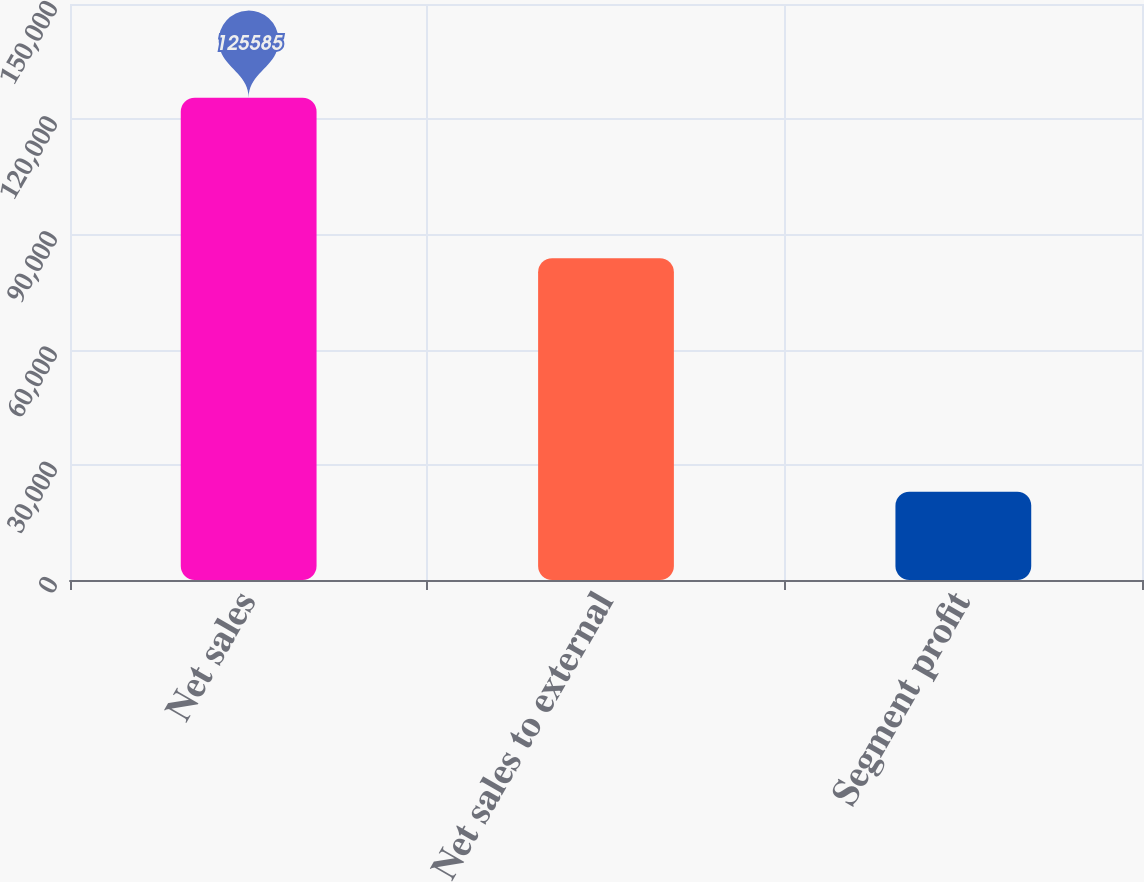<chart> <loc_0><loc_0><loc_500><loc_500><bar_chart><fcel>Net sales<fcel>Net sales to external<fcel>Segment profit<nl><fcel>125585<fcel>83789<fcel>22983<nl></chart> 